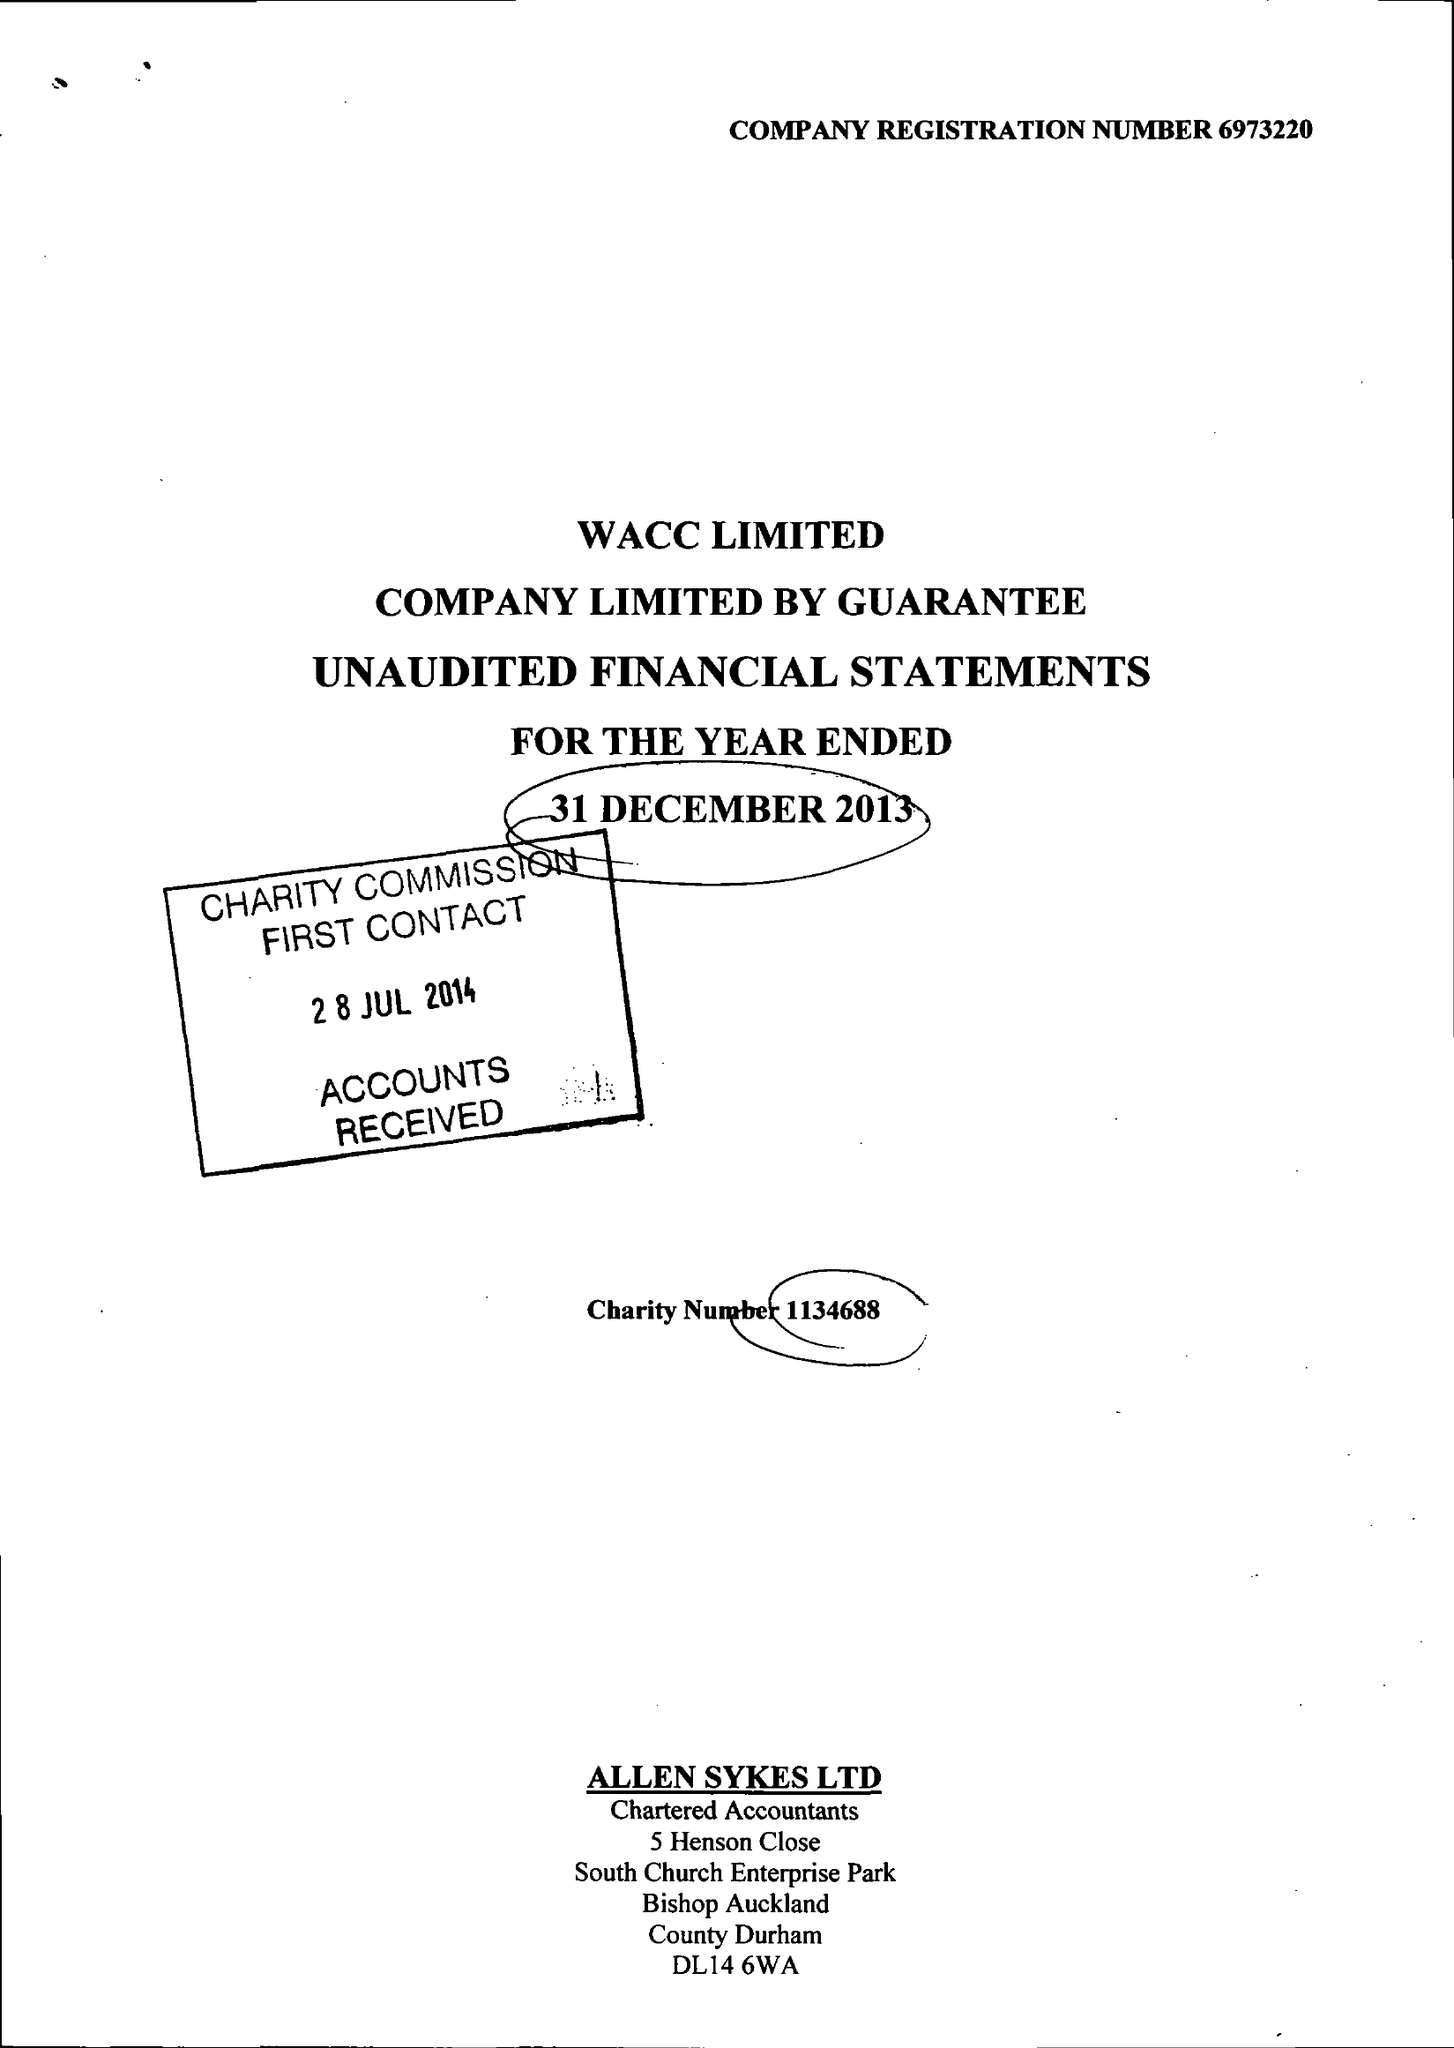What is the value for the address__post_town?
Answer the question using a single word or phrase. BISHOP AUCKLAND 